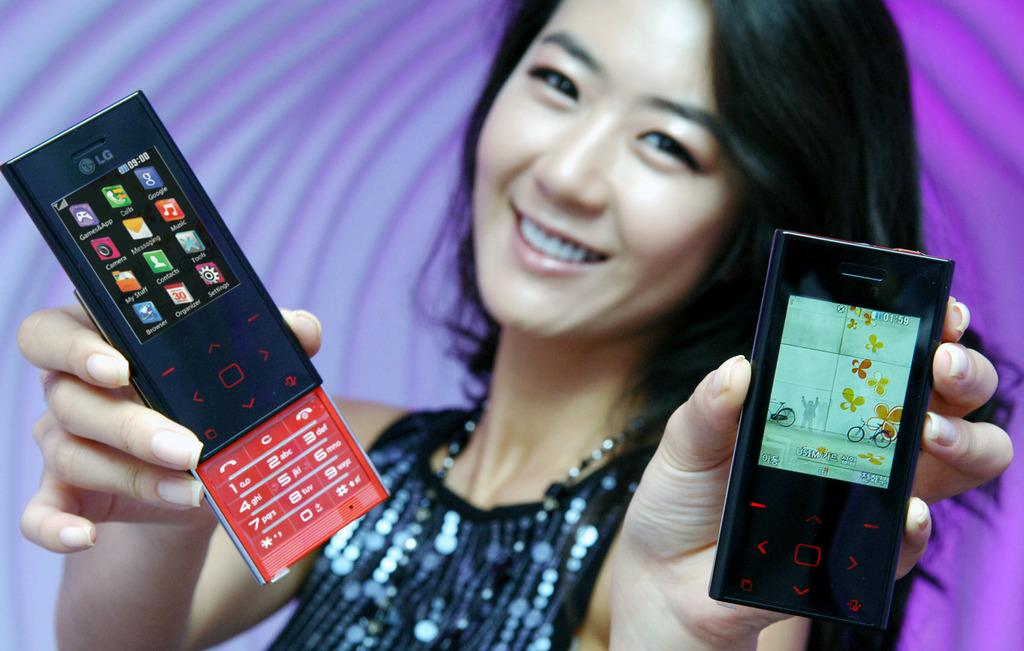Who is present in the image? There is a woman in the image. What is the woman holding in the image? The woman is holding cell phones. What type of library can be seen in the background of the image? There is no library present in the image; it only features a woman holding cell phones. 